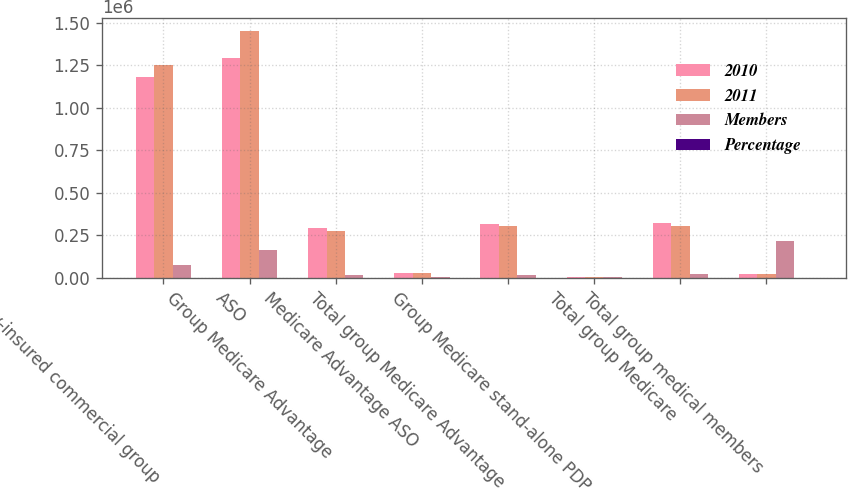<chart> <loc_0><loc_0><loc_500><loc_500><stacked_bar_chart><ecel><fcel>Fully-insured commercial group<fcel>ASO<fcel>Group Medicare Advantage<fcel>Medicare Advantage ASO<fcel>Total group Medicare Advantage<fcel>Group Medicare stand-alone PDP<fcel>Total group Medicare<fcel>Total group medical members<nl><fcel>2010<fcel>1.1802e+06<fcel>1.2923e+06<fcel>290600<fcel>27600<fcel>318200<fcel>4200<fcel>322400<fcel>23150<nl><fcel>2011<fcel>1.2522e+06<fcel>1.4536e+06<fcel>273100<fcel>28200<fcel>301300<fcel>2400<fcel>303700<fcel>23150<nl><fcel>Members<fcel>72000<fcel>161300<fcel>17500<fcel>600<fcel>16900<fcel>1800<fcel>18700<fcel>214600<nl><fcel>Percentage<fcel>5.7<fcel>11.1<fcel>6.4<fcel>2.1<fcel>5.6<fcel>75<fcel>6.2<fcel>7.1<nl></chart> 